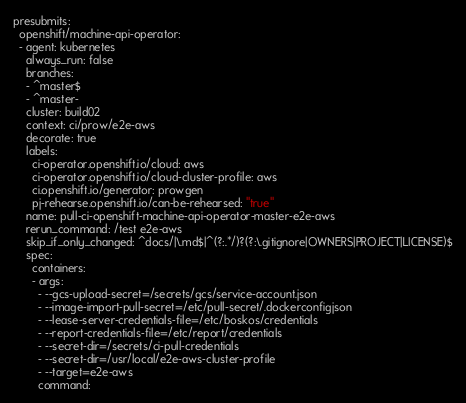<code> <loc_0><loc_0><loc_500><loc_500><_YAML_>presubmits:
  openshift/machine-api-operator:
  - agent: kubernetes
    always_run: false
    branches:
    - ^master$
    - ^master-
    cluster: build02
    context: ci/prow/e2e-aws
    decorate: true
    labels:
      ci-operator.openshift.io/cloud: aws
      ci-operator.openshift.io/cloud-cluster-profile: aws
      ci.openshift.io/generator: prowgen
      pj-rehearse.openshift.io/can-be-rehearsed: "true"
    name: pull-ci-openshift-machine-api-operator-master-e2e-aws
    rerun_command: /test e2e-aws
    skip_if_only_changed: ^docs/|\.md$|^(?:.*/)?(?:\.gitignore|OWNERS|PROJECT|LICENSE)$
    spec:
      containers:
      - args:
        - --gcs-upload-secret=/secrets/gcs/service-account.json
        - --image-import-pull-secret=/etc/pull-secret/.dockerconfigjson
        - --lease-server-credentials-file=/etc/boskos/credentials
        - --report-credentials-file=/etc/report/credentials
        - --secret-dir=/secrets/ci-pull-credentials
        - --secret-dir=/usr/local/e2e-aws-cluster-profile
        - --target=e2e-aws
        command:</code> 